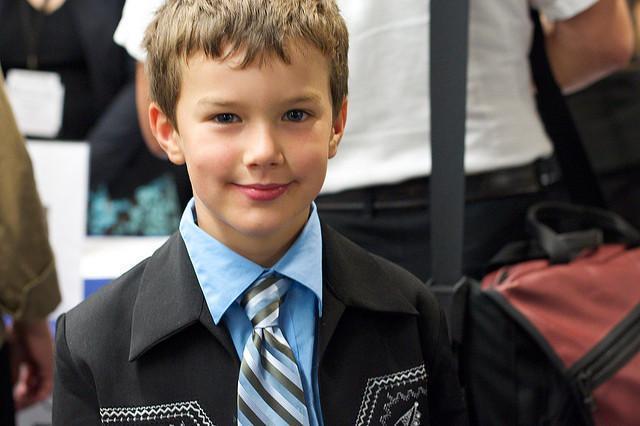How many people are there?
Give a very brief answer. 3. 